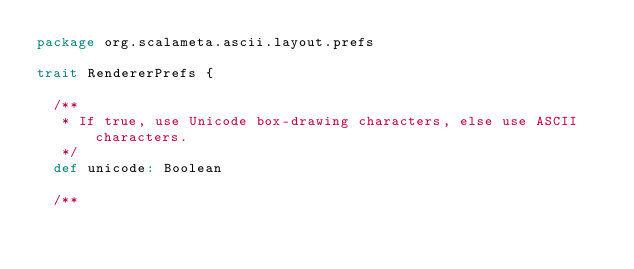Convert code to text. <code><loc_0><loc_0><loc_500><loc_500><_Scala_>package org.scalameta.ascii.layout.prefs

trait RendererPrefs {

  /**
   * If true, use Unicode box-drawing characters, else use ASCII characters.
   */
  def unicode: Boolean

  /**</code> 